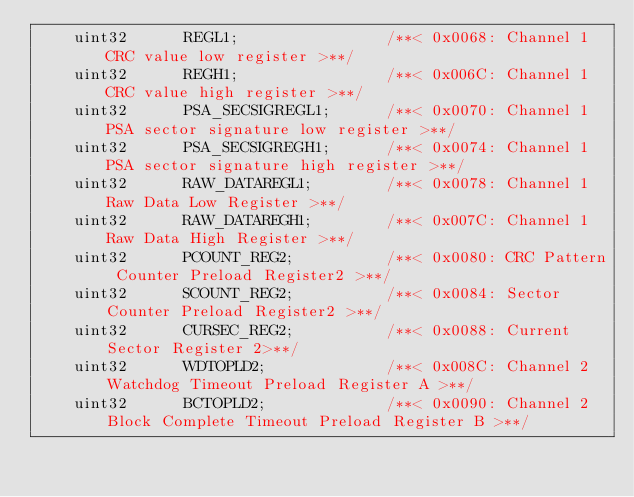Convert code to text. <code><loc_0><loc_0><loc_500><loc_500><_C_>    uint32      REGL1;                /**< 0x0068: Channel 1 CRC value low register >**/
    uint32      REGH1;                /**< 0x006C: Channel 1 CRC value high register >**/
    uint32      PSA_SECSIGREGL1;      /**< 0x0070: Channel 1 PSA sector signature low register >**/
    uint32      PSA_SECSIGREGH1;      /**< 0x0074: Channel 1 PSA sector signature high register >**/
    uint32      RAW_DATAREGL1;        /**< 0x0078: Channel 1 Raw Data Low Register >**/
    uint32      RAW_DATAREGH1;        /**< 0x007C: Channel 1 Raw Data High Register >**/
    uint32      PCOUNT_REG2;          /**< 0x0080: CRC Pattern Counter Preload Register2 >**/
    uint32      SCOUNT_REG2;          /**< 0x0084: Sector Counter Preload Register2 >**/
    uint32      CURSEC_REG2;          /**< 0x0088: Current Sector Register 2>**/
    uint32      WDTOPLD2;             /**< 0x008C: Channel 2 Watchdog Timeout Preload Register A >**/
    uint32      BCTOPLD2;             /**< 0x0090: Channel 2 Block Complete Timeout Preload Register B >**/</code> 